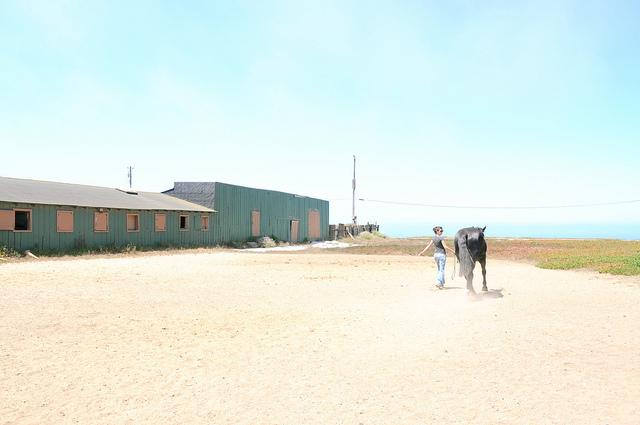What is next to the animal?
Keep it brief. Woman. What time of day is this picture taken?
Answer briefly. Afternoon. Is that building made out of bricks?
Be succinct. No. What color is the building?
Answer briefly. Green. How many trees are in the picture?
Answer briefly. 0. How many legs does this crow have?
Answer briefly. 0. What animal is in the picture?
Give a very brief answer. Horse. Who took the picture?
Concise answer only. Photographer. Could you get a good sun tan in this sort of weather?
Write a very short answer. Yes. Is it a cool day?
Short answer required. No. What is the tan area behind the animals?
Be succinct. Sand. Can you swim here?
Quick response, please. No. 